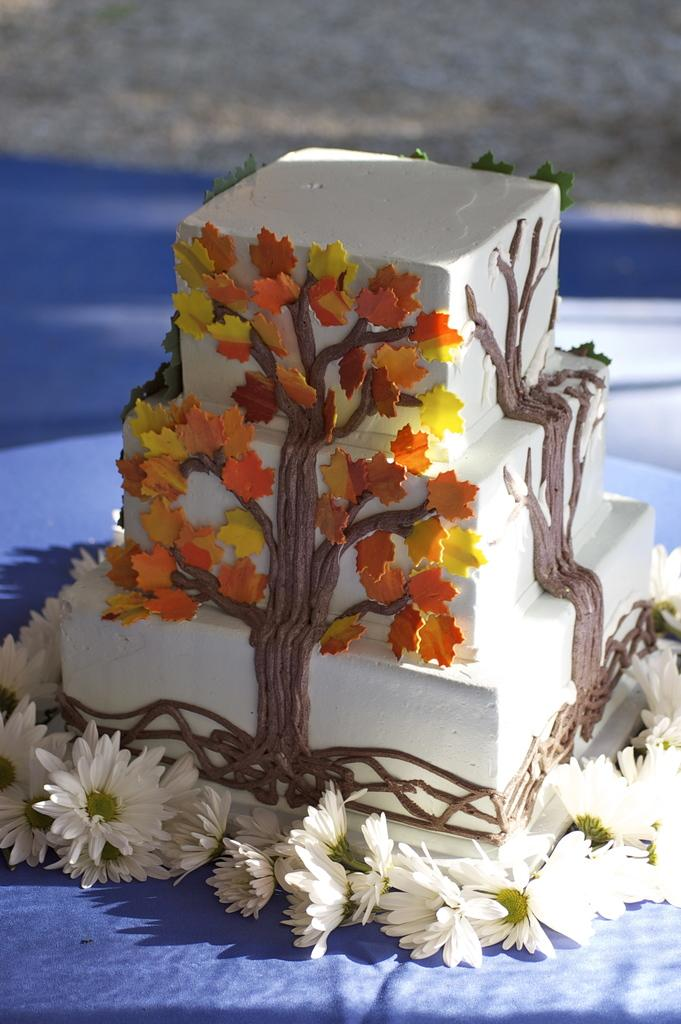What is the main subject of the image? The main subject of the image is a cake. Are there any decorations or additional elements around the cake? Yes, there are white color flowers around the cake. How many balloons are tied to the yak in the image? There is no yak or balloons present in the image; it only features a cake with white color flowers around it. 